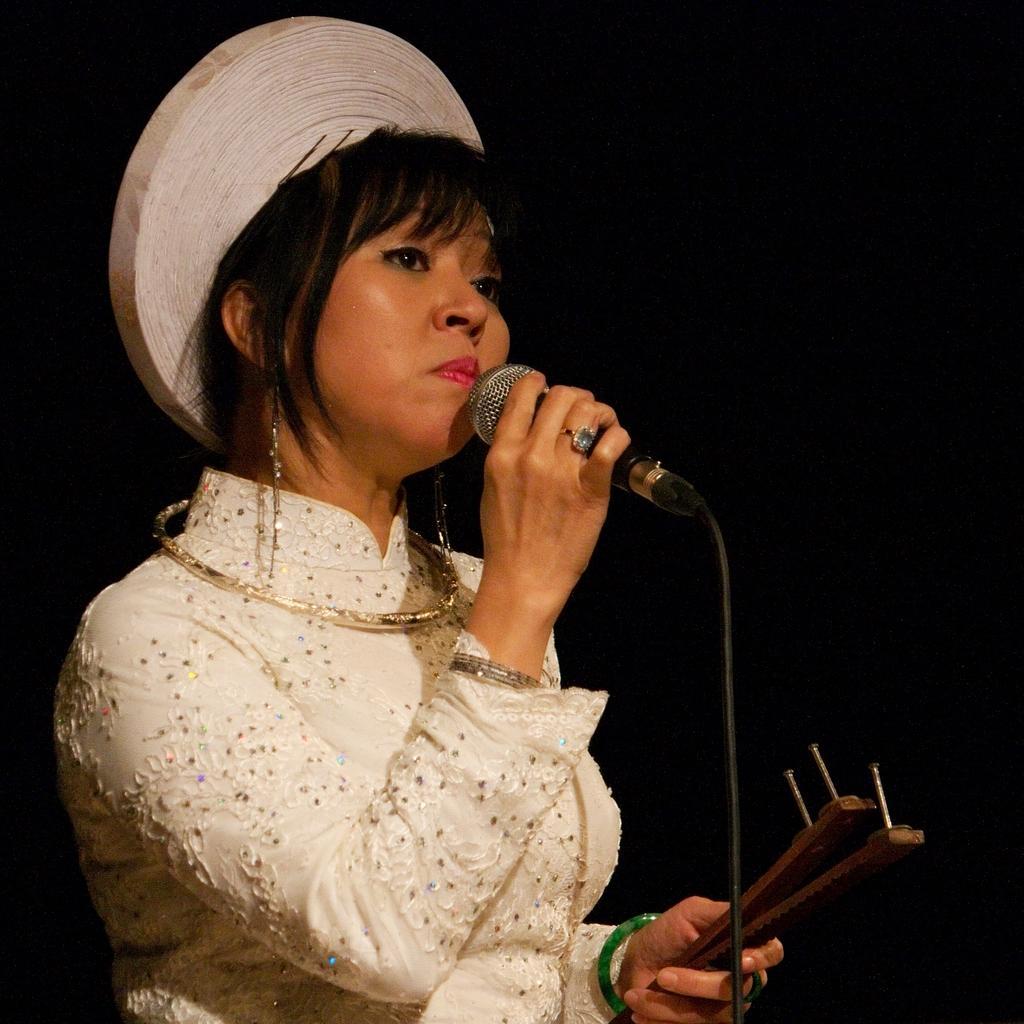Please provide a concise description of this image. In this is image a lady is holding a mic and few other things. She is wearing a white dress and white cap. 